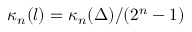<formula> <loc_0><loc_0><loc_500><loc_500>\kappa _ { n } ( l ) = \kappa _ { n } ( \Delta ) / ( 2 ^ { n } - 1 )</formula> 